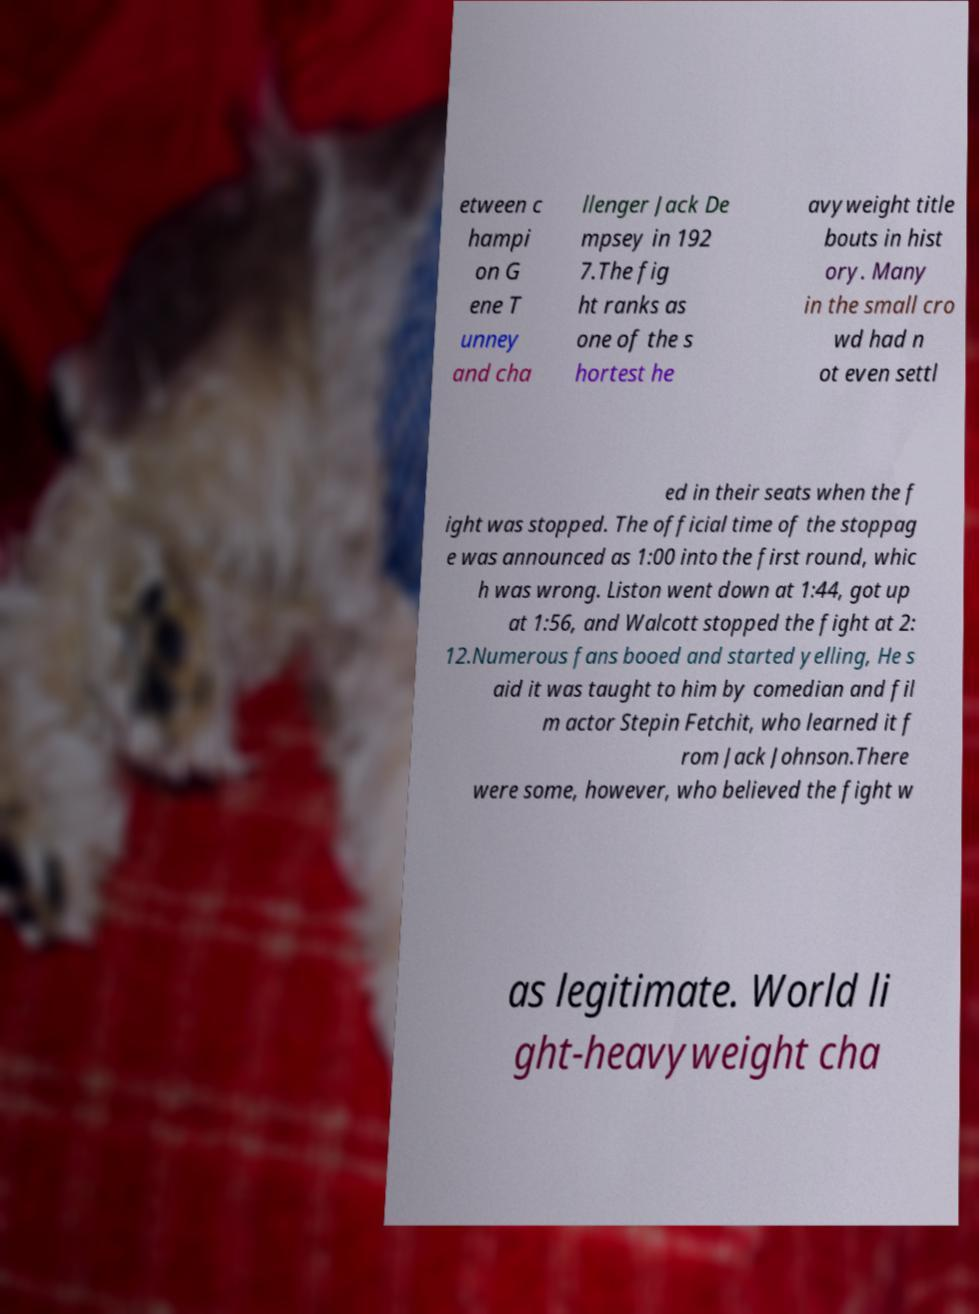What messages or text are displayed in this image? I need them in a readable, typed format. etween c hampi on G ene T unney and cha llenger Jack De mpsey in 192 7.The fig ht ranks as one of the s hortest he avyweight title bouts in hist ory. Many in the small cro wd had n ot even settl ed in their seats when the f ight was stopped. The official time of the stoppag e was announced as 1:00 into the first round, whic h was wrong. Liston went down at 1:44, got up at 1:56, and Walcott stopped the fight at 2: 12.Numerous fans booed and started yelling, He s aid it was taught to him by comedian and fil m actor Stepin Fetchit, who learned it f rom Jack Johnson.There were some, however, who believed the fight w as legitimate. World li ght-heavyweight cha 